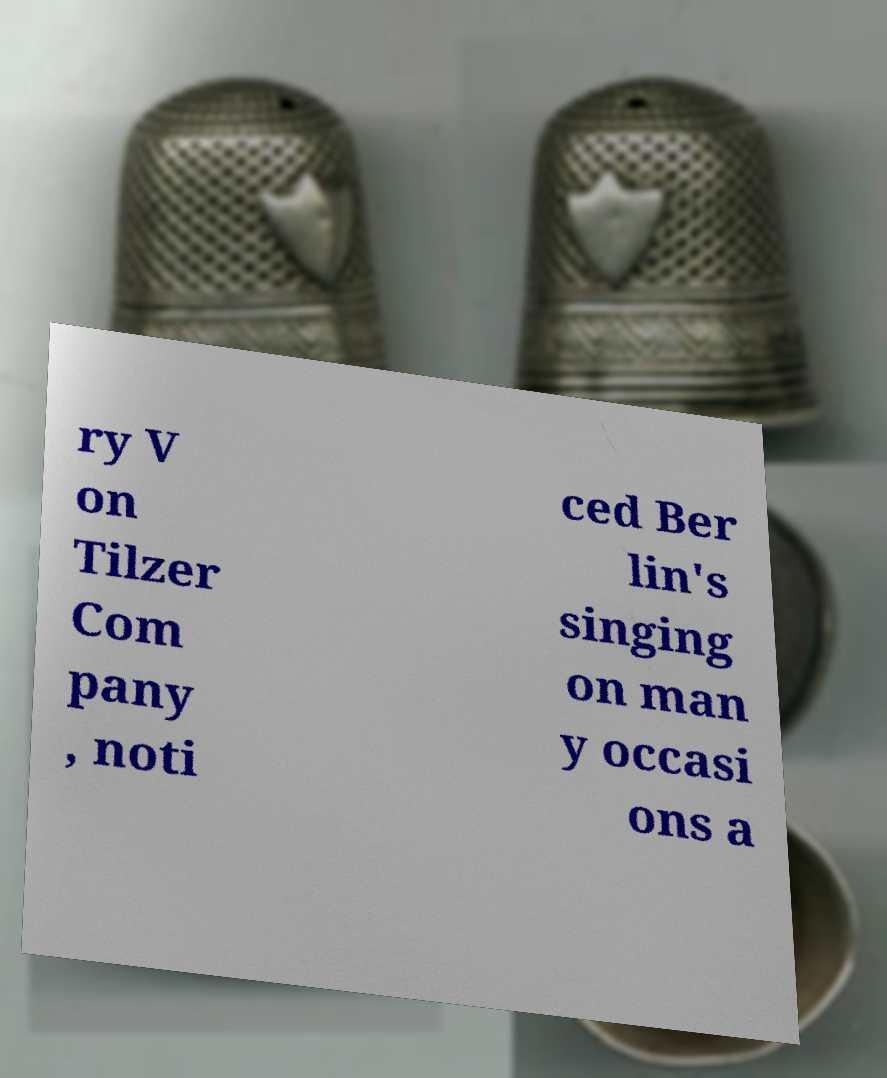Could you assist in decoding the text presented in this image and type it out clearly? ry V on Tilzer Com pany , noti ced Ber lin's singing on man y occasi ons a 